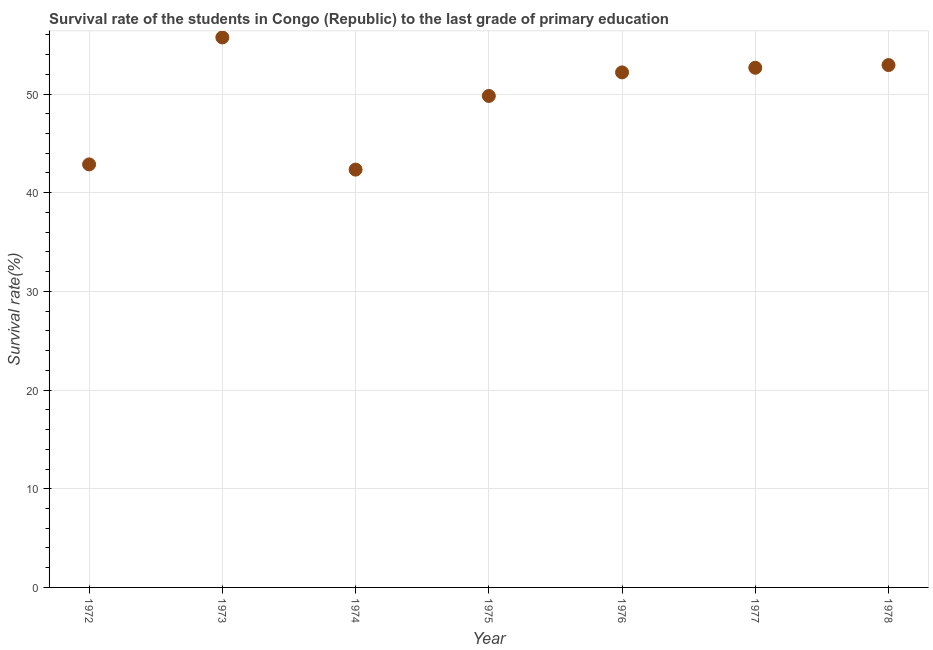What is the survival rate in primary education in 1973?
Ensure brevity in your answer.  55.74. Across all years, what is the maximum survival rate in primary education?
Your answer should be compact. 55.74. Across all years, what is the minimum survival rate in primary education?
Ensure brevity in your answer.  42.34. In which year was the survival rate in primary education maximum?
Keep it short and to the point. 1973. In which year was the survival rate in primary education minimum?
Give a very brief answer. 1974. What is the sum of the survival rate in primary education?
Your answer should be very brief. 348.54. What is the difference between the survival rate in primary education in 1974 and 1978?
Provide a succinct answer. -10.6. What is the average survival rate in primary education per year?
Your response must be concise. 49.79. What is the median survival rate in primary education?
Your answer should be very brief. 52.19. What is the ratio of the survival rate in primary education in 1973 to that in 1976?
Provide a short and direct response. 1.07. What is the difference between the highest and the second highest survival rate in primary education?
Offer a terse response. 2.8. What is the difference between the highest and the lowest survival rate in primary education?
Offer a very short reply. 13.39. How many years are there in the graph?
Ensure brevity in your answer.  7. Are the values on the major ticks of Y-axis written in scientific E-notation?
Provide a short and direct response. No. Does the graph contain any zero values?
Give a very brief answer. No. What is the title of the graph?
Your answer should be very brief. Survival rate of the students in Congo (Republic) to the last grade of primary education. What is the label or title of the Y-axis?
Ensure brevity in your answer.  Survival rate(%). What is the Survival rate(%) in 1972?
Make the answer very short. 42.87. What is the Survival rate(%) in 1973?
Provide a short and direct response. 55.74. What is the Survival rate(%) in 1974?
Provide a short and direct response. 42.34. What is the Survival rate(%) in 1975?
Ensure brevity in your answer.  49.81. What is the Survival rate(%) in 1976?
Provide a succinct answer. 52.19. What is the Survival rate(%) in 1977?
Provide a short and direct response. 52.66. What is the Survival rate(%) in 1978?
Give a very brief answer. 52.94. What is the difference between the Survival rate(%) in 1972 and 1973?
Provide a succinct answer. -12.87. What is the difference between the Survival rate(%) in 1972 and 1974?
Your answer should be very brief. 0.53. What is the difference between the Survival rate(%) in 1972 and 1975?
Your response must be concise. -6.94. What is the difference between the Survival rate(%) in 1972 and 1976?
Ensure brevity in your answer.  -9.32. What is the difference between the Survival rate(%) in 1972 and 1977?
Make the answer very short. -9.79. What is the difference between the Survival rate(%) in 1972 and 1978?
Give a very brief answer. -10.07. What is the difference between the Survival rate(%) in 1973 and 1974?
Offer a very short reply. 13.39. What is the difference between the Survival rate(%) in 1973 and 1975?
Your answer should be compact. 5.93. What is the difference between the Survival rate(%) in 1973 and 1976?
Provide a succinct answer. 3.54. What is the difference between the Survival rate(%) in 1973 and 1977?
Provide a short and direct response. 3.07. What is the difference between the Survival rate(%) in 1973 and 1978?
Provide a succinct answer. 2.8. What is the difference between the Survival rate(%) in 1974 and 1975?
Keep it short and to the point. -7.47. What is the difference between the Survival rate(%) in 1974 and 1976?
Ensure brevity in your answer.  -9.85. What is the difference between the Survival rate(%) in 1974 and 1977?
Give a very brief answer. -10.32. What is the difference between the Survival rate(%) in 1974 and 1978?
Offer a very short reply. -10.6. What is the difference between the Survival rate(%) in 1975 and 1976?
Your response must be concise. -2.39. What is the difference between the Survival rate(%) in 1975 and 1977?
Offer a very short reply. -2.86. What is the difference between the Survival rate(%) in 1975 and 1978?
Make the answer very short. -3.13. What is the difference between the Survival rate(%) in 1976 and 1977?
Keep it short and to the point. -0.47. What is the difference between the Survival rate(%) in 1976 and 1978?
Your answer should be compact. -0.74. What is the difference between the Survival rate(%) in 1977 and 1978?
Ensure brevity in your answer.  -0.27. What is the ratio of the Survival rate(%) in 1972 to that in 1973?
Your answer should be very brief. 0.77. What is the ratio of the Survival rate(%) in 1972 to that in 1975?
Your answer should be very brief. 0.86. What is the ratio of the Survival rate(%) in 1972 to that in 1976?
Keep it short and to the point. 0.82. What is the ratio of the Survival rate(%) in 1972 to that in 1977?
Make the answer very short. 0.81. What is the ratio of the Survival rate(%) in 1972 to that in 1978?
Ensure brevity in your answer.  0.81. What is the ratio of the Survival rate(%) in 1973 to that in 1974?
Ensure brevity in your answer.  1.32. What is the ratio of the Survival rate(%) in 1973 to that in 1975?
Your answer should be compact. 1.12. What is the ratio of the Survival rate(%) in 1973 to that in 1976?
Your answer should be very brief. 1.07. What is the ratio of the Survival rate(%) in 1973 to that in 1977?
Keep it short and to the point. 1.06. What is the ratio of the Survival rate(%) in 1973 to that in 1978?
Make the answer very short. 1.05. What is the ratio of the Survival rate(%) in 1974 to that in 1975?
Keep it short and to the point. 0.85. What is the ratio of the Survival rate(%) in 1974 to that in 1976?
Offer a terse response. 0.81. What is the ratio of the Survival rate(%) in 1974 to that in 1977?
Your answer should be very brief. 0.8. What is the ratio of the Survival rate(%) in 1974 to that in 1978?
Provide a succinct answer. 0.8. What is the ratio of the Survival rate(%) in 1975 to that in 1976?
Give a very brief answer. 0.95. What is the ratio of the Survival rate(%) in 1975 to that in 1977?
Provide a succinct answer. 0.95. What is the ratio of the Survival rate(%) in 1975 to that in 1978?
Your answer should be compact. 0.94. 